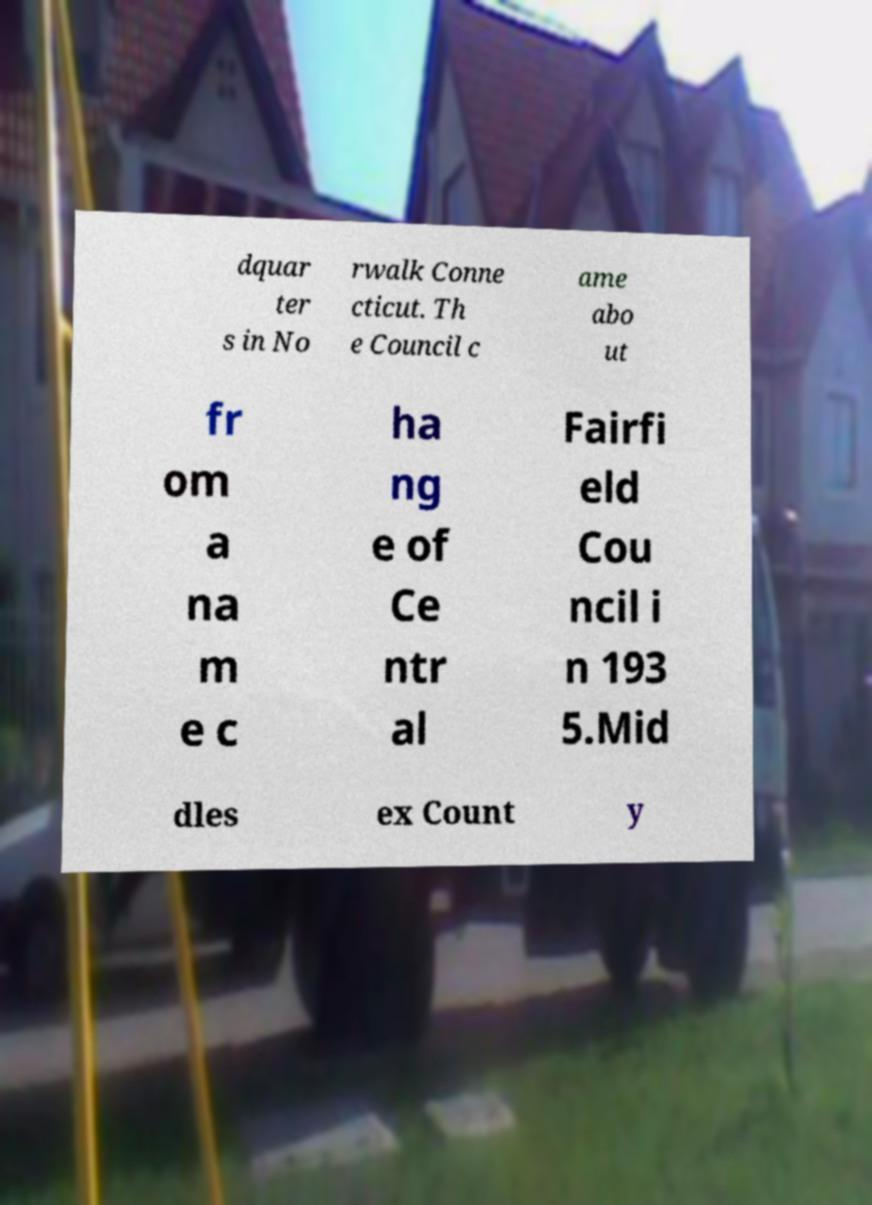Could you assist in decoding the text presented in this image and type it out clearly? dquar ter s in No rwalk Conne cticut. Th e Council c ame abo ut fr om a na m e c ha ng e of Ce ntr al Fairfi eld Cou ncil i n 193 5.Mid dles ex Count y 